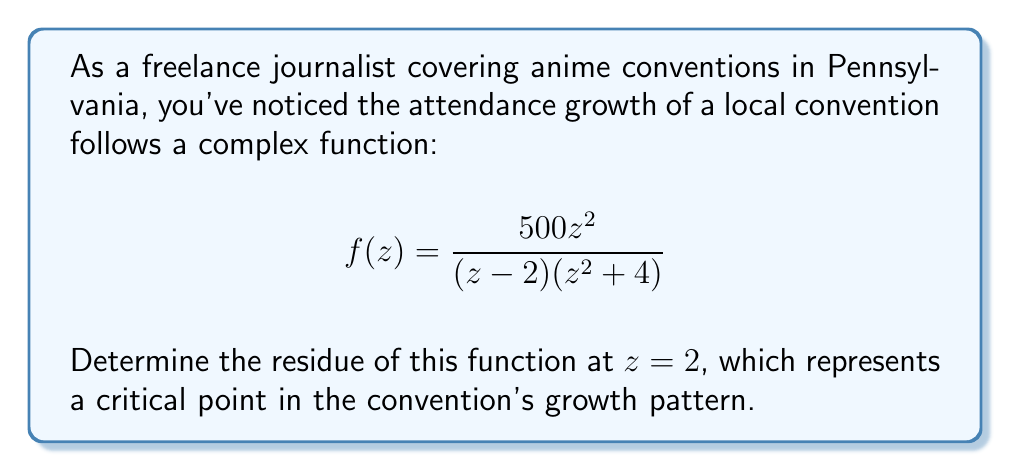Can you answer this question? To find the residue at $z = 2$, we need to follow these steps:

1) First, we observe that $z = 2$ is a simple pole of $f(z)$ because it's a root of the denominator with multiplicity 1.

2) For a simple pole, we can use the formula:

   $$\text{Res}(f,2) = \lim_{z \to 2} (z-2)f(z)$$

3) Let's substitute the function:

   $$\text{Res}(f,2) = \lim_{z \to 2} (z-2)\frac{500z^2}{(z-2)(z^2+4)}$$

4) The $(z-2)$ terms cancel out:

   $$\text{Res}(f,2) = \lim_{z \to 2} \frac{500z^2}{z^2+4}$$

5) Now we can directly substitute $z = 2$:

   $$\text{Res}(f,2) = \frac{500(2)^2}{2^2+4} = \frac{2000}{8} = 250$$

Therefore, the residue of $f(z)$ at $z = 2$ is 250.
Answer: 250 